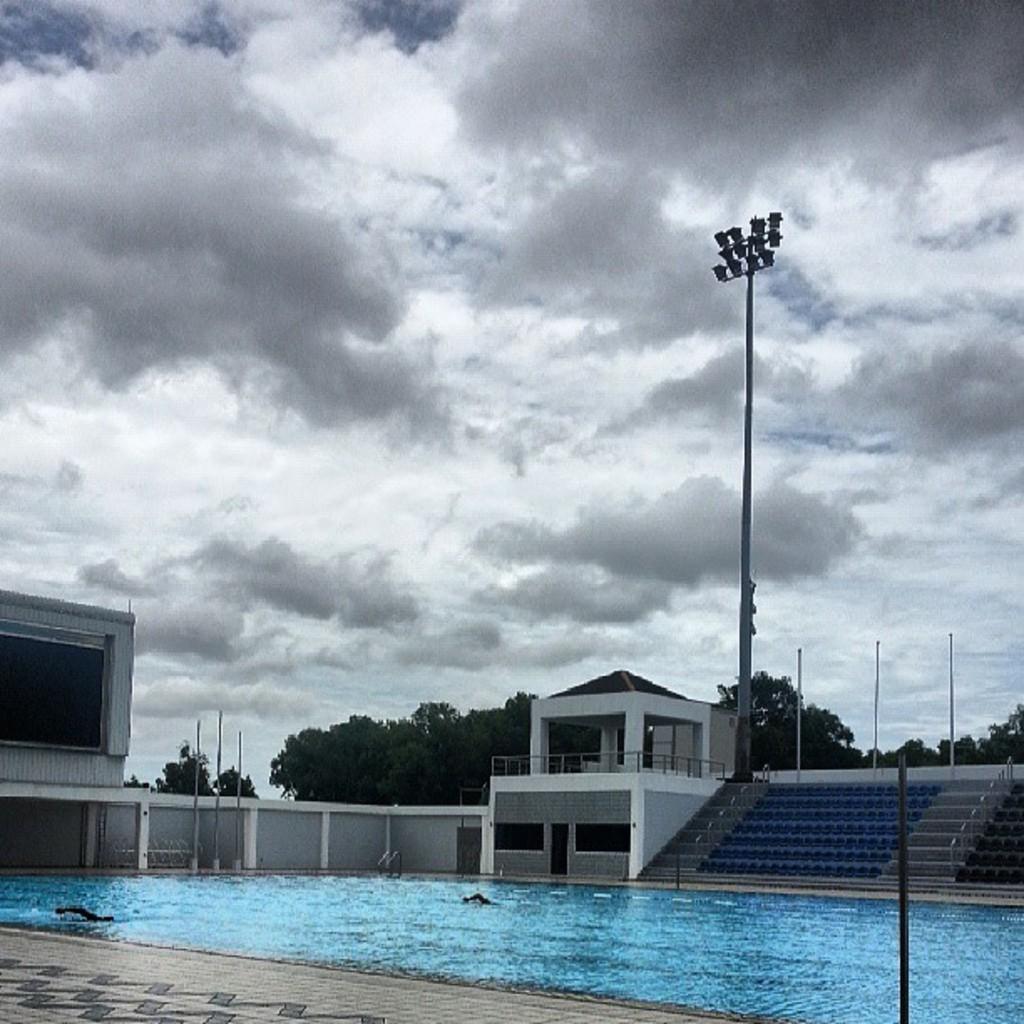Describe this image in one or two sentences. In this image I can see few trees, building, light pole, poles, water, stairs and the sky is in white color. 